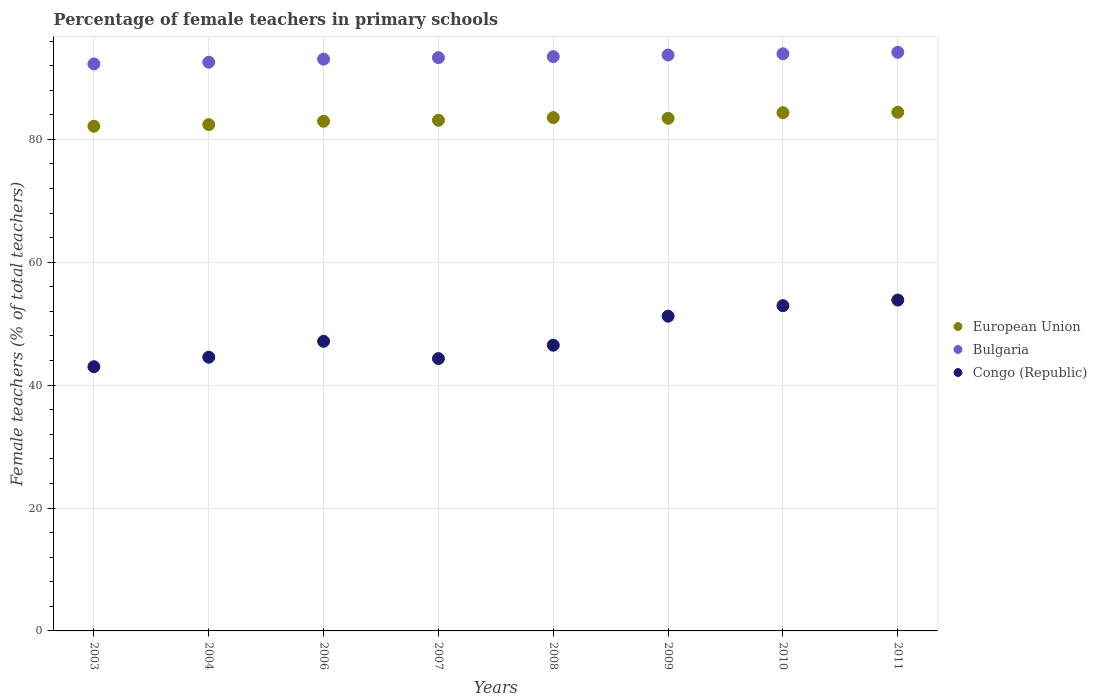How many different coloured dotlines are there?
Your answer should be very brief. 3. Is the number of dotlines equal to the number of legend labels?
Provide a short and direct response. Yes. What is the percentage of female teachers in European Union in 2004?
Make the answer very short. 82.4. Across all years, what is the maximum percentage of female teachers in Congo (Republic)?
Provide a short and direct response. 53.85. Across all years, what is the minimum percentage of female teachers in European Union?
Offer a very short reply. 82.14. In which year was the percentage of female teachers in Bulgaria maximum?
Offer a terse response. 2011. What is the total percentage of female teachers in European Union in the graph?
Provide a succinct answer. 666.35. What is the difference between the percentage of female teachers in European Union in 2003 and that in 2007?
Make the answer very short. -0.98. What is the difference between the percentage of female teachers in Congo (Republic) in 2009 and the percentage of female teachers in European Union in 2007?
Ensure brevity in your answer.  -31.89. What is the average percentage of female teachers in Bulgaria per year?
Offer a very short reply. 93.31. In the year 2009, what is the difference between the percentage of female teachers in European Union and percentage of female teachers in Bulgaria?
Ensure brevity in your answer.  -10.3. What is the ratio of the percentage of female teachers in European Union in 2007 to that in 2008?
Your response must be concise. 0.99. Is the percentage of female teachers in European Union in 2003 less than that in 2004?
Offer a terse response. Yes. Is the difference between the percentage of female teachers in European Union in 2006 and 2008 greater than the difference between the percentage of female teachers in Bulgaria in 2006 and 2008?
Ensure brevity in your answer.  No. What is the difference between the highest and the second highest percentage of female teachers in Bulgaria?
Provide a succinct answer. 0.24. What is the difference between the highest and the lowest percentage of female teachers in European Union?
Keep it short and to the point. 2.28. In how many years, is the percentage of female teachers in Bulgaria greater than the average percentage of female teachers in Bulgaria taken over all years?
Give a very brief answer. 4. Is the sum of the percentage of female teachers in Bulgaria in 2008 and 2009 greater than the maximum percentage of female teachers in European Union across all years?
Make the answer very short. Yes. Is the percentage of female teachers in Bulgaria strictly less than the percentage of female teachers in Congo (Republic) over the years?
Ensure brevity in your answer.  No. Does the graph contain any zero values?
Provide a short and direct response. No. Where does the legend appear in the graph?
Give a very brief answer. Center right. How many legend labels are there?
Your response must be concise. 3. What is the title of the graph?
Make the answer very short. Percentage of female teachers in primary schools. Does "Cabo Verde" appear as one of the legend labels in the graph?
Provide a succinct answer. No. What is the label or title of the X-axis?
Make the answer very short. Years. What is the label or title of the Y-axis?
Make the answer very short. Female teachers (% of total teachers). What is the Female teachers (% of total teachers) in European Union in 2003?
Keep it short and to the point. 82.14. What is the Female teachers (% of total teachers) in Bulgaria in 2003?
Your answer should be compact. 92.27. What is the Female teachers (% of total teachers) of Congo (Republic) in 2003?
Your response must be concise. 43. What is the Female teachers (% of total teachers) in European Union in 2004?
Keep it short and to the point. 82.4. What is the Female teachers (% of total teachers) of Bulgaria in 2004?
Your answer should be very brief. 92.56. What is the Female teachers (% of total teachers) of Congo (Republic) in 2004?
Offer a very short reply. 44.55. What is the Female teachers (% of total teachers) in European Union in 2006?
Your answer should be compact. 82.95. What is the Female teachers (% of total teachers) in Bulgaria in 2006?
Offer a terse response. 93.06. What is the Female teachers (% of total teachers) of Congo (Republic) in 2006?
Provide a short and direct response. 47.13. What is the Female teachers (% of total teachers) in European Union in 2007?
Give a very brief answer. 83.11. What is the Female teachers (% of total teachers) of Bulgaria in 2007?
Give a very brief answer. 93.3. What is the Female teachers (% of total teachers) in Congo (Republic) in 2007?
Provide a short and direct response. 44.32. What is the Female teachers (% of total teachers) of European Union in 2008?
Make the answer very short. 83.55. What is the Female teachers (% of total teachers) in Bulgaria in 2008?
Give a very brief answer. 93.47. What is the Female teachers (% of total teachers) of Congo (Republic) in 2008?
Keep it short and to the point. 46.5. What is the Female teachers (% of total teachers) in European Union in 2009?
Give a very brief answer. 83.43. What is the Female teachers (% of total teachers) in Bulgaria in 2009?
Provide a short and direct response. 93.73. What is the Female teachers (% of total teachers) in Congo (Republic) in 2009?
Give a very brief answer. 51.22. What is the Female teachers (% of total teachers) in European Union in 2010?
Keep it short and to the point. 84.35. What is the Female teachers (% of total teachers) in Bulgaria in 2010?
Ensure brevity in your answer.  93.93. What is the Female teachers (% of total teachers) of Congo (Republic) in 2010?
Offer a terse response. 52.94. What is the Female teachers (% of total teachers) in European Union in 2011?
Keep it short and to the point. 84.42. What is the Female teachers (% of total teachers) in Bulgaria in 2011?
Make the answer very short. 94.17. What is the Female teachers (% of total teachers) of Congo (Republic) in 2011?
Keep it short and to the point. 53.85. Across all years, what is the maximum Female teachers (% of total teachers) in European Union?
Make the answer very short. 84.42. Across all years, what is the maximum Female teachers (% of total teachers) in Bulgaria?
Provide a short and direct response. 94.17. Across all years, what is the maximum Female teachers (% of total teachers) of Congo (Republic)?
Ensure brevity in your answer.  53.85. Across all years, what is the minimum Female teachers (% of total teachers) in European Union?
Your response must be concise. 82.14. Across all years, what is the minimum Female teachers (% of total teachers) of Bulgaria?
Give a very brief answer. 92.27. Across all years, what is the minimum Female teachers (% of total teachers) of Congo (Republic)?
Make the answer very short. 43. What is the total Female teachers (% of total teachers) of European Union in the graph?
Your answer should be compact. 666.35. What is the total Female teachers (% of total teachers) of Bulgaria in the graph?
Your answer should be compact. 746.5. What is the total Female teachers (% of total teachers) in Congo (Republic) in the graph?
Provide a succinct answer. 383.52. What is the difference between the Female teachers (% of total teachers) in European Union in 2003 and that in 2004?
Provide a succinct answer. -0.27. What is the difference between the Female teachers (% of total teachers) in Bulgaria in 2003 and that in 2004?
Offer a terse response. -0.29. What is the difference between the Female teachers (% of total teachers) of Congo (Republic) in 2003 and that in 2004?
Ensure brevity in your answer.  -1.54. What is the difference between the Female teachers (% of total teachers) in European Union in 2003 and that in 2006?
Provide a short and direct response. -0.82. What is the difference between the Female teachers (% of total teachers) of Bulgaria in 2003 and that in 2006?
Give a very brief answer. -0.79. What is the difference between the Female teachers (% of total teachers) in Congo (Republic) in 2003 and that in 2006?
Your answer should be very brief. -4.13. What is the difference between the Female teachers (% of total teachers) of European Union in 2003 and that in 2007?
Keep it short and to the point. -0.98. What is the difference between the Female teachers (% of total teachers) of Bulgaria in 2003 and that in 2007?
Ensure brevity in your answer.  -1.03. What is the difference between the Female teachers (% of total teachers) in Congo (Republic) in 2003 and that in 2007?
Your response must be concise. -1.32. What is the difference between the Female teachers (% of total teachers) of European Union in 2003 and that in 2008?
Your answer should be very brief. -1.41. What is the difference between the Female teachers (% of total teachers) of Bulgaria in 2003 and that in 2008?
Your answer should be compact. -1.19. What is the difference between the Female teachers (% of total teachers) in Congo (Republic) in 2003 and that in 2008?
Give a very brief answer. -3.5. What is the difference between the Female teachers (% of total teachers) in European Union in 2003 and that in 2009?
Provide a short and direct response. -1.29. What is the difference between the Female teachers (% of total teachers) in Bulgaria in 2003 and that in 2009?
Your answer should be compact. -1.46. What is the difference between the Female teachers (% of total teachers) in Congo (Republic) in 2003 and that in 2009?
Make the answer very short. -8.22. What is the difference between the Female teachers (% of total teachers) of European Union in 2003 and that in 2010?
Your answer should be very brief. -2.21. What is the difference between the Female teachers (% of total teachers) in Bulgaria in 2003 and that in 2010?
Offer a very short reply. -1.66. What is the difference between the Female teachers (% of total teachers) of Congo (Republic) in 2003 and that in 2010?
Provide a succinct answer. -9.93. What is the difference between the Female teachers (% of total teachers) of European Union in 2003 and that in 2011?
Give a very brief answer. -2.28. What is the difference between the Female teachers (% of total teachers) in Bulgaria in 2003 and that in 2011?
Make the answer very short. -1.9. What is the difference between the Female teachers (% of total teachers) of Congo (Republic) in 2003 and that in 2011?
Make the answer very short. -10.85. What is the difference between the Female teachers (% of total teachers) of European Union in 2004 and that in 2006?
Provide a short and direct response. -0.55. What is the difference between the Female teachers (% of total teachers) in Bulgaria in 2004 and that in 2006?
Give a very brief answer. -0.5. What is the difference between the Female teachers (% of total teachers) in Congo (Republic) in 2004 and that in 2006?
Provide a succinct answer. -2.59. What is the difference between the Female teachers (% of total teachers) of European Union in 2004 and that in 2007?
Offer a terse response. -0.71. What is the difference between the Female teachers (% of total teachers) of Bulgaria in 2004 and that in 2007?
Your answer should be very brief. -0.74. What is the difference between the Female teachers (% of total teachers) of Congo (Republic) in 2004 and that in 2007?
Provide a succinct answer. 0.22. What is the difference between the Female teachers (% of total teachers) of European Union in 2004 and that in 2008?
Your answer should be compact. -1.15. What is the difference between the Female teachers (% of total teachers) in Bulgaria in 2004 and that in 2008?
Your answer should be compact. -0.91. What is the difference between the Female teachers (% of total teachers) of Congo (Republic) in 2004 and that in 2008?
Provide a succinct answer. -1.96. What is the difference between the Female teachers (% of total teachers) of European Union in 2004 and that in 2009?
Your answer should be compact. -1.03. What is the difference between the Female teachers (% of total teachers) in Bulgaria in 2004 and that in 2009?
Offer a terse response. -1.17. What is the difference between the Female teachers (% of total teachers) of Congo (Republic) in 2004 and that in 2009?
Offer a very short reply. -6.68. What is the difference between the Female teachers (% of total teachers) in European Union in 2004 and that in 2010?
Offer a terse response. -1.94. What is the difference between the Female teachers (% of total teachers) in Bulgaria in 2004 and that in 2010?
Make the answer very short. -1.37. What is the difference between the Female teachers (% of total teachers) in Congo (Republic) in 2004 and that in 2010?
Make the answer very short. -8.39. What is the difference between the Female teachers (% of total teachers) of European Union in 2004 and that in 2011?
Offer a terse response. -2.01. What is the difference between the Female teachers (% of total teachers) of Bulgaria in 2004 and that in 2011?
Your answer should be compact. -1.61. What is the difference between the Female teachers (% of total teachers) of Congo (Republic) in 2004 and that in 2011?
Your answer should be compact. -9.31. What is the difference between the Female teachers (% of total teachers) in European Union in 2006 and that in 2007?
Your answer should be compact. -0.16. What is the difference between the Female teachers (% of total teachers) of Bulgaria in 2006 and that in 2007?
Make the answer very short. -0.24. What is the difference between the Female teachers (% of total teachers) in Congo (Republic) in 2006 and that in 2007?
Give a very brief answer. 2.81. What is the difference between the Female teachers (% of total teachers) in European Union in 2006 and that in 2008?
Offer a terse response. -0.59. What is the difference between the Female teachers (% of total teachers) in Bulgaria in 2006 and that in 2008?
Make the answer very short. -0.41. What is the difference between the Female teachers (% of total teachers) in Congo (Republic) in 2006 and that in 2008?
Your answer should be very brief. 0.63. What is the difference between the Female teachers (% of total teachers) of European Union in 2006 and that in 2009?
Give a very brief answer. -0.48. What is the difference between the Female teachers (% of total teachers) in Bulgaria in 2006 and that in 2009?
Make the answer very short. -0.67. What is the difference between the Female teachers (% of total teachers) in Congo (Republic) in 2006 and that in 2009?
Provide a succinct answer. -4.09. What is the difference between the Female teachers (% of total teachers) of European Union in 2006 and that in 2010?
Keep it short and to the point. -1.39. What is the difference between the Female teachers (% of total teachers) of Bulgaria in 2006 and that in 2010?
Keep it short and to the point. -0.87. What is the difference between the Female teachers (% of total teachers) in Congo (Republic) in 2006 and that in 2010?
Your response must be concise. -5.81. What is the difference between the Female teachers (% of total teachers) in European Union in 2006 and that in 2011?
Give a very brief answer. -1.46. What is the difference between the Female teachers (% of total teachers) of Bulgaria in 2006 and that in 2011?
Offer a terse response. -1.11. What is the difference between the Female teachers (% of total teachers) of Congo (Republic) in 2006 and that in 2011?
Provide a succinct answer. -6.72. What is the difference between the Female teachers (% of total teachers) in European Union in 2007 and that in 2008?
Provide a short and direct response. -0.44. What is the difference between the Female teachers (% of total teachers) of Bulgaria in 2007 and that in 2008?
Your response must be concise. -0.17. What is the difference between the Female teachers (% of total teachers) in Congo (Republic) in 2007 and that in 2008?
Offer a very short reply. -2.18. What is the difference between the Female teachers (% of total teachers) of European Union in 2007 and that in 2009?
Your answer should be compact. -0.32. What is the difference between the Female teachers (% of total teachers) of Bulgaria in 2007 and that in 2009?
Ensure brevity in your answer.  -0.43. What is the difference between the Female teachers (% of total teachers) of Congo (Republic) in 2007 and that in 2009?
Ensure brevity in your answer.  -6.9. What is the difference between the Female teachers (% of total teachers) of European Union in 2007 and that in 2010?
Offer a very short reply. -1.23. What is the difference between the Female teachers (% of total teachers) in Bulgaria in 2007 and that in 2010?
Provide a succinct answer. -0.63. What is the difference between the Female teachers (% of total teachers) in Congo (Republic) in 2007 and that in 2010?
Provide a short and direct response. -8.61. What is the difference between the Female teachers (% of total teachers) of European Union in 2007 and that in 2011?
Offer a terse response. -1.3. What is the difference between the Female teachers (% of total teachers) in Bulgaria in 2007 and that in 2011?
Give a very brief answer. -0.87. What is the difference between the Female teachers (% of total teachers) in Congo (Republic) in 2007 and that in 2011?
Your answer should be compact. -9.53. What is the difference between the Female teachers (% of total teachers) of European Union in 2008 and that in 2009?
Your answer should be compact. 0.12. What is the difference between the Female teachers (% of total teachers) of Bulgaria in 2008 and that in 2009?
Give a very brief answer. -0.27. What is the difference between the Female teachers (% of total teachers) of Congo (Republic) in 2008 and that in 2009?
Make the answer very short. -4.72. What is the difference between the Female teachers (% of total teachers) in European Union in 2008 and that in 2010?
Ensure brevity in your answer.  -0.8. What is the difference between the Female teachers (% of total teachers) of Bulgaria in 2008 and that in 2010?
Ensure brevity in your answer.  -0.47. What is the difference between the Female teachers (% of total teachers) of Congo (Republic) in 2008 and that in 2010?
Give a very brief answer. -6.44. What is the difference between the Female teachers (% of total teachers) in European Union in 2008 and that in 2011?
Offer a very short reply. -0.87. What is the difference between the Female teachers (% of total teachers) in Bulgaria in 2008 and that in 2011?
Keep it short and to the point. -0.71. What is the difference between the Female teachers (% of total teachers) in Congo (Republic) in 2008 and that in 2011?
Provide a short and direct response. -7.35. What is the difference between the Female teachers (% of total teachers) in European Union in 2009 and that in 2010?
Offer a very short reply. -0.92. What is the difference between the Female teachers (% of total teachers) in Bulgaria in 2009 and that in 2010?
Make the answer very short. -0.2. What is the difference between the Female teachers (% of total teachers) of Congo (Republic) in 2009 and that in 2010?
Offer a very short reply. -1.72. What is the difference between the Female teachers (% of total teachers) in European Union in 2009 and that in 2011?
Your response must be concise. -0.98. What is the difference between the Female teachers (% of total teachers) in Bulgaria in 2009 and that in 2011?
Your answer should be very brief. -0.44. What is the difference between the Female teachers (% of total teachers) of Congo (Republic) in 2009 and that in 2011?
Give a very brief answer. -2.63. What is the difference between the Female teachers (% of total teachers) of European Union in 2010 and that in 2011?
Provide a succinct answer. -0.07. What is the difference between the Female teachers (% of total teachers) of Bulgaria in 2010 and that in 2011?
Offer a terse response. -0.24. What is the difference between the Female teachers (% of total teachers) of Congo (Republic) in 2010 and that in 2011?
Ensure brevity in your answer.  -0.92. What is the difference between the Female teachers (% of total teachers) in European Union in 2003 and the Female teachers (% of total teachers) in Bulgaria in 2004?
Offer a very short reply. -10.42. What is the difference between the Female teachers (% of total teachers) of European Union in 2003 and the Female teachers (% of total teachers) of Congo (Republic) in 2004?
Your answer should be compact. 37.59. What is the difference between the Female teachers (% of total teachers) of Bulgaria in 2003 and the Female teachers (% of total teachers) of Congo (Republic) in 2004?
Make the answer very short. 47.73. What is the difference between the Female teachers (% of total teachers) of European Union in 2003 and the Female teachers (% of total teachers) of Bulgaria in 2006?
Ensure brevity in your answer.  -10.92. What is the difference between the Female teachers (% of total teachers) of European Union in 2003 and the Female teachers (% of total teachers) of Congo (Republic) in 2006?
Provide a succinct answer. 35.01. What is the difference between the Female teachers (% of total teachers) of Bulgaria in 2003 and the Female teachers (% of total teachers) of Congo (Republic) in 2006?
Your answer should be very brief. 45.14. What is the difference between the Female teachers (% of total teachers) in European Union in 2003 and the Female teachers (% of total teachers) in Bulgaria in 2007?
Your answer should be compact. -11.16. What is the difference between the Female teachers (% of total teachers) of European Union in 2003 and the Female teachers (% of total teachers) of Congo (Republic) in 2007?
Offer a terse response. 37.81. What is the difference between the Female teachers (% of total teachers) of Bulgaria in 2003 and the Female teachers (% of total teachers) of Congo (Republic) in 2007?
Offer a terse response. 47.95. What is the difference between the Female teachers (% of total teachers) of European Union in 2003 and the Female teachers (% of total teachers) of Bulgaria in 2008?
Provide a succinct answer. -11.33. What is the difference between the Female teachers (% of total teachers) in European Union in 2003 and the Female teachers (% of total teachers) in Congo (Republic) in 2008?
Provide a succinct answer. 35.63. What is the difference between the Female teachers (% of total teachers) of Bulgaria in 2003 and the Female teachers (% of total teachers) of Congo (Republic) in 2008?
Ensure brevity in your answer.  45.77. What is the difference between the Female teachers (% of total teachers) in European Union in 2003 and the Female teachers (% of total teachers) in Bulgaria in 2009?
Offer a very short reply. -11.59. What is the difference between the Female teachers (% of total teachers) of European Union in 2003 and the Female teachers (% of total teachers) of Congo (Republic) in 2009?
Offer a terse response. 30.92. What is the difference between the Female teachers (% of total teachers) in Bulgaria in 2003 and the Female teachers (% of total teachers) in Congo (Republic) in 2009?
Provide a short and direct response. 41.05. What is the difference between the Female teachers (% of total teachers) in European Union in 2003 and the Female teachers (% of total teachers) in Bulgaria in 2010?
Your response must be concise. -11.8. What is the difference between the Female teachers (% of total teachers) of European Union in 2003 and the Female teachers (% of total teachers) of Congo (Republic) in 2010?
Give a very brief answer. 29.2. What is the difference between the Female teachers (% of total teachers) of Bulgaria in 2003 and the Female teachers (% of total teachers) of Congo (Republic) in 2010?
Ensure brevity in your answer.  39.34. What is the difference between the Female teachers (% of total teachers) in European Union in 2003 and the Female teachers (% of total teachers) in Bulgaria in 2011?
Keep it short and to the point. -12.04. What is the difference between the Female teachers (% of total teachers) in European Union in 2003 and the Female teachers (% of total teachers) in Congo (Republic) in 2011?
Your answer should be very brief. 28.28. What is the difference between the Female teachers (% of total teachers) in Bulgaria in 2003 and the Female teachers (% of total teachers) in Congo (Republic) in 2011?
Your answer should be very brief. 38.42. What is the difference between the Female teachers (% of total teachers) of European Union in 2004 and the Female teachers (% of total teachers) of Bulgaria in 2006?
Provide a short and direct response. -10.66. What is the difference between the Female teachers (% of total teachers) of European Union in 2004 and the Female teachers (% of total teachers) of Congo (Republic) in 2006?
Provide a succinct answer. 35.27. What is the difference between the Female teachers (% of total teachers) in Bulgaria in 2004 and the Female teachers (% of total teachers) in Congo (Republic) in 2006?
Your response must be concise. 45.43. What is the difference between the Female teachers (% of total teachers) of European Union in 2004 and the Female teachers (% of total teachers) of Bulgaria in 2007?
Your answer should be compact. -10.9. What is the difference between the Female teachers (% of total teachers) in European Union in 2004 and the Female teachers (% of total teachers) in Congo (Republic) in 2007?
Give a very brief answer. 38.08. What is the difference between the Female teachers (% of total teachers) in Bulgaria in 2004 and the Female teachers (% of total teachers) in Congo (Republic) in 2007?
Keep it short and to the point. 48.24. What is the difference between the Female teachers (% of total teachers) in European Union in 2004 and the Female teachers (% of total teachers) in Bulgaria in 2008?
Offer a terse response. -11.06. What is the difference between the Female teachers (% of total teachers) in European Union in 2004 and the Female teachers (% of total teachers) in Congo (Republic) in 2008?
Provide a succinct answer. 35.9. What is the difference between the Female teachers (% of total teachers) in Bulgaria in 2004 and the Female teachers (% of total teachers) in Congo (Republic) in 2008?
Provide a short and direct response. 46.06. What is the difference between the Female teachers (% of total teachers) of European Union in 2004 and the Female teachers (% of total teachers) of Bulgaria in 2009?
Provide a succinct answer. -11.33. What is the difference between the Female teachers (% of total teachers) in European Union in 2004 and the Female teachers (% of total teachers) in Congo (Republic) in 2009?
Your answer should be compact. 31.18. What is the difference between the Female teachers (% of total teachers) of Bulgaria in 2004 and the Female teachers (% of total teachers) of Congo (Republic) in 2009?
Offer a terse response. 41.34. What is the difference between the Female teachers (% of total teachers) in European Union in 2004 and the Female teachers (% of total teachers) in Bulgaria in 2010?
Offer a terse response. -11.53. What is the difference between the Female teachers (% of total teachers) of European Union in 2004 and the Female teachers (% of total teachers) of Congo (Republic) in 2010?
Make the answer very short. 29.46. What is the difference between the Female teachers (% of total teachers) of Bulgaria in 2004 and the Female teachers (% of total teachers) of Congo (Republic) in 2010?
Provide a short and direct response. 39.62. What is the difference between the Female teachers (% of total teachers) in European Union in 2004 and the Female teachers (% of total teachers) in Bulgaria in 2011?
Provide a succinct answer. -11.77. What is the difference between the Female teachers (% of total teachers) in European Union in 2004 and the Female teachers (% of total teachers) in Congo (Republic) in 2011?
Your answer should be compact. 28.55. What is the difference between the Female teachers (% of total teachers) of Bulgaria in 2004 and the Female teachers (% of total teachers) of Congo (Republic) in 2011?
Make the answer very short. 38.71. What is the difference between the Female teachers (% of total teachers) of European Union in 2006 and the Female teachers (% of total teachers) of Bulgaria in 2007?
Your answer should be compact. -10.34. What is the difference between the Female teachers (% of total teachers) in European Union in 2006 and the Female teachers (% of total teachers) in Congo (Republic) in 2007?
Make the answer very short. 38.63. What is the difference between the Female teachers (% of total teachers) in Bulgaria in 2006 and the Female teachers (% of total teachers) in Congo (Republic) in 2007?
Make the answer very short. 48.74. What is the difference between the Female teachers (% of total teachers) of European Union in 2006 and the Female teachers (% of total teachers) of Bulgaria in 2008?
Offer a terse response. -10.51. What is the difference between the Female teachers (% of total teachers) in European Union in 2006 and the Female teachers (% of total teachers) in Congo (Republic) in 2008?
Give a very brief answer. 36.45. What is the difference between the Female teachers (% of total teachers) of Bulgaria in 2006 and the Female teachers (% of total teachers) of Congo (Republic) in 2008?
Ensure brevity in your answer.  46.56. What is the difference between the Female teachers (% of total teachers) of European Union in 2006 and the Female teachers (% of total teachers) of Bulgaria in 2009?
Provide a succinct answer. -10.78. What is the difference between the Female teachers (% of total teachers) in European Union in 2006 and the Female teachers (% of total teachers) in Congo (Republic) in 2009?
Provide a short and direct response. 31.73. What is the difference between the Female teachers (% of total teachers) of Bulgaria in 2006 and the Female teachers (% of total teachers) of Congo (Republic) in 2009?
Offer a terse response. 41.84. What is the difference between the Female teachers (% of total teachers) of European Union in 2006 and the Female teachers (% of total teachers) of Bulgaria in 2010?
Your response must be concise. -10.98. What is the difference between the Female teachers (% of total teachers) in European Union in 2006 and the Female teachers (% of total teachers) in Congo (Republic) in 2010?
Offer a terse response. 30.02. What is the difference between the Female teachers (% of total teachers) of Bulgaria in 2006 and the Female teachers (% of total teachers) of Congo (Republic) in 2010?
Your response must be concise. 40.12. What is the difference between the Female teachers (% of total teachers) in European Union in 2006 and the Female teachers (% of total teachers) in Bulgaria in 2011?
Keep it short and to the point. -11.22. What is the difference between the Female teachers (% of total teachers) in European Union in 2006 and the Female teachers (% of total teachers) in Congo (Republic) in 2011?
Your response must be concise. 29.1. What is the difference between the Female teachers (% of total teachers) of Bulgaria in 2006 and the Female teachers (% of total teachers) of Congo (Republic) in 2011?
Your answer should be compact. 39.21. What is the difference between the Female teachers (% of total teachers) of European Union in 2007 and the Female teachers (% of total teachers) of Bulgaria in 2008?
Provide a short and direct response. -10.35. What is the difference between the Female teachers (% of total teachers) of European Union in 2007 and the Female teachers (% of total teachers) of Congo (Republic) in 2008?
Your answer should be compact. 36.61. What is the difference between the Female teachers (% of total teachers) in Bulgaria in 2007 and the Female teachers (% of total teachers) in Congo (Republic) in 2008?
Offer a terse response. 46.8. What is the difference between the Female teachers (% of total teachers) in European Union in 2007 and the Female teachers (% of total teachers) in Bulgaria in 2009?
Provide a short and direct response. -10.62. What is the difference between the Female teachers (% of total teachers) in European Union in 2007 and the Female teachers (% of total teachers) in Congo (Republic) in 2009?
Make the answer very short. 31.89. What is the difference between the Female teachers (% of total teachers) in Bulgaria in 2007 and the Female teachers (% of total teachers) in Congo (Republic) in 2009?
Offer a very short reply. 42.08. What is the difference between the Female teachers (% of total teachers) in European Union in 2007 and the Female teachers (% of total teachers) in Bulgaria in 2010?
Provide a succinct answer. -10.82. What is the difference between the Female teachers (% of total teachers) of European Union in 2007 and the Female teachers (% of total teachers) of Congo (Republic) in 2010?
Provide a short and direct response. 30.18. What is the difference between the Female teachers (% of total teachers) of Bulgaria in 2007 and the Female teachers (% of total teachers) of Congo (Republic) in 2010?
Provide a short and direct response. 40.36. What is the difference between the Female teachers (% of total teachers) of European Union in 2007 and the Female teachers (% of total teachers) of Bulgaria in 2011?
Ensure brevity in your answer.  -11.06. What is the difference between the Female teachers (% of total teachers) in European Union in 2007 and the Female teachers (% of total teachers) in Congo (Republic) in 2011?
Offer a terse response. 29.26. What is the difference between the Female teachers (% of total teachers) of Bulgaria in 2007 and the Female teachers (% of total teachers) of Congo (Republic) in 2011?
Offer a terse response. 39.45. What is the difference between the Female teachers (% of total teachers) in European Union in 2008 and the Female teachers (% of total teachers) in Bulgaria in 2009?
Ensure brevity in your answer.  -10.18. What is the difference between the Female teachers (% of total teachers) of European Union in 2008 and the Female teachers (% of total teachers) of Congo (Republic) in 2009?
Your response must be concise. 32.33. What is the difference between the Female teachers (% of total teachers) of Bulgaria in 2008 and the Female teachers (% of total teachers) of Congo (Republic) in 2009?
Provide a succinct answer. 42.24. What is the difference between the Female teachers (% of total teachers) of European Union in 2008 and the Female teachers (% of total teachers) of Bulgaria in 2010?
Provide a succinct answer. -10.38. What is the difference between the Female teachers (% of total teachers) in European Union in 2008 and the Female teachers (% of total teachers) in Congo (Republic) in 2010?
Provide a short and direct response. 30.61. What is the difference between the Female teachers (% of total teachers) of Bulgaria in 2008 and the Female teachers (% of total teachers) of Congo (Republic) in 2010?
Your answer should be compact. 40.53. What is the difference between the Female teachers (% of total teachers) of European Union in 2008 and the Female teachers (% of total teachers) of Bulgaria in 2011?
Provide a succinct answer. -10.62. What is the difference between the Female teachers (% of total teachers) of European Union in 2008 and the Female teachers (% of total teachers) of Congo (Republic) in 2011?
Make the answer very short. 29.7. What is the difference between the Female teachers (% of total teachers) in Bulgaria in 2008 and the Female teachers (% of total teachers) in Congo (Republic) in 2011?
Provide a succinct answer. 39.61. What is the difference between the Female teachers (% of total teachers) in European Union in 2009 and the Female teachers (% of total teachers) in Bulgaria in 2010?
Provide a short and direct response. -10.5. What is the difference between the Female teachers (% of total teachers) of European Union in 2009 and the Female teachers (% of total teachers) of Congo (Republic) in 2010?
Keep it short and to the point. 30.49. What is the difference between the Female teachers (% of total teachers) in Bulgaria in 2009 and the Female teachers (% of total teachers) in Congo (Republic) in 2010?
Keep it short and to the point. 40.79. What is the difference between the Female teachers (% of total teachers) in European Union in 2009 and the Female teachers (% of total teachers) in Bulgaria in 2011?
Your answer should be very brief. -10.74. What is the difference between the Female teachers (% of total teachers) in European Union in 2009 and the Female teachers (% of total teachers) in Congo (Republic) in 2011?
Keep it short and to the point. 29.58. What is the difference between the Female teachers (% of total teachers) in Bulgaria in 2009 and the Female teachers (% of total teachers) in Congo (Republic) in 2011?
Offer a terse response. 39.88. What is the difference between the Female teachers (% of total teachers) in European Union in 2010 and the Female teachers (% of total teachers) in Bulgaria in 2011?
Provide a succinct answer. -9.83. What is the difference between the Female teachers (% of total teachers) in European Union in 2010 and the Female teachers (% of total teachers) in Congo (Republic) in 2011?
Offer a very short reply. 30.49. What is the difference between the Female teachers (% of total teachers) in Bulgaria in 2010 and the Female teachers (% of total teachers) in Congo (Republic) in 2011?
Provide a succinct answer. 40.08. What is the average Female teachers (% of total teachers) of European Union per year?
Keep it short and to the point. 83.29. What is the average Female teachers (% of total teachers) in Bulgaria per year?
Ensure brevity in your answer.  93.31. What is the average Female teachers (% of total teachers) in Congo (Republic) per year?
Your answer should be compact. 47.94. In the year 2003, what is the difference between the Female teachers (% of total teachers) in European Union and Female teachers (% of total teachers) in Bulgaria?
Offer a very short reply. -10.14. In the year 2003, what is the difference between the Female teachers (% of total teachers) of European Union and Female teachers (% of total teachers) of Congo (Republic)?
Your answer should be very brief. 39.13. In the year 2003, what is the difference between the Female teachers (% of total teachers) in Bulgaria and Female teachers (% of total teachers) in Congo (Republic)?
Offer a terse response. 49.27. In the year 2004, what is the difference between the Female teachers (% of total teachers) in European Union and Female teachers (% of total teachers) in Bulgaria?
Your response must be concise. -10.16. In the year 2004, what is the difference between the Female teachers (% of total teachers) in European Union and Female teachers (% of total teachers) in Congo (Republic)?
Offer a very short reply. 37.86. In the year 2004, what is the difference between the Female teachers (% of total teachers) in Bulgaria and Female teachers (% of total teachers) in Congo (Republic)?
Provide a short and direct response. 48.01. In the year 2006, what is the difference between the Female teachers (% of total teachers) in European Union and Female teachers (% of total teachers) in Bulgaria?
Give a very brief answer. -10.11. In the year 2006, what is the difference between the Female teachers (% of total teachers) of European Union and Female teachers (% of total teachers) of Congo (Republic)?
Keep it short and to the point. 35.82. In the year 2006, what is the difference between the Female teachers (% of total teachers) in Bulgaria and Female teachers (% of total teachers) in Congo (Republic)?
Keep it short and to the point. 45.93. In the year 2007, what is the difference between the Female teachers (% of total teachers) of European Union and Female teachers (% of total teachers) of Bulgaria?
Ensure brevity in your answer.  -10.19. In the year 2007, what is the difference between the Female teachers (% of total teachers) in European Union and Female teachers (% of total teachers) in Congo (Republic)?
Give a very brief answer. 38.79. In the year 2007, what is the difference between the Female teachers (% of total teachers) of Bulgaria and Female teachers (% of total teachers) of Congo (Republic)?
Provide a succinct answer. 48.98. In the year 2008, what is the difference between the Female teachers (% of total teachers) in European Union and Female teachers (% of total teachers) in Bulgaria?
Ensure brevity in your answer.  -9.92. In the year 2008, what is the difference between the Female teachers (% of total teachers) of European Union and Female teachers (% of total teachers) of Congo (Republic)?
Provide a succinct answer. 37.05. In the year 2008, what is the difference between the Female teachers (% of total teachers) in Bulgaria and Female teachers (% of total teachers) in Congo (Republic)?
Your answer should be compact. 46.96. In the year 2009, what is the difference between the Female teachers (% of total teachers) in European Union and Female teachers (% of total teachers) in Bulgaria?
Your response must be concise. -10.3. In the year 2009, what is the difference between the Female teachers (% of total teachers) in European Union and Female teachers (% of total teachers) in Congo (Republic)?
Make the answer very short. 32.21. In the year 2009, what is the difference between the Female teachers (% of total teachers) of Bulgaria and Female teachers (% of total teachers) of Congo (Republic)?
Your answer should be compact. 42.51. In the year 2010, what is the difference between the Female teachers (% of total teachers) in European Union and Female teachers (% of total teachers) in Bulgaria?
Provide a short and direct response. -9.59. In the year 2010, what is the difference between the Female teachers (% of total teachers) of European Union and Female teachers (% of total teachers) of Congo (Republic)?
Ensure brevity in your answer.  31.41. In the year 2010, what is the difference between the Female teachers (% of total teachers) of Bulgaria and Female teachers (% of total teachers) of Congo (Republic)?
Offer a terse response. 41. In the year 2011, what is the difference between the Female teachers (% of total teachers) of European Union and Female teachers (% of total teachers) of Bulgaria?
Keep it short and to the point. -9.76. In the year 2011, what is the difference between the Female teachers (% of total teachers) of European Union and Female teachers (% of total teachers) of Congo (Republic)?
Make the answer very short. 30.56. In the year 2011, what is the difference between the Female teachers (% of total teachers) of Bulgaria and Female teachers (% of total teachers) of Congo (Republic)?
Offer a very short reply. 40.32. What is the ratio of the Female teachers (% of total teachers) of European Union in 2003 to that in 2004?
Ensure brevity in your answer.  1. What is the ratio of the Female teachers (% of total teachers) in Bulgaria in 2003 to that in 2004?
Offer a very short reply. 1. What is the ratio of the Female teachers (% of total teachers) of Congo (Republic) in 2003 to that in 2004?
Offer a very short reply. 0.97. What is the ratio of the Female teachers (% of total teachers) in Bulgaria in 2003 to that in 2006?
Offer a terse response. 0.99. What is the ratio of the Female teachers (% of total teachers) of Congo (Republic) in 2003 to that in 2006?
Offer a terse response. 0.91. What is the ratio of the Female teachers (% of total teachers) in European Union in 2003 to that in 2007?
Keep it short and to the point. 0.99. What is the ratio of the Female teachers (% of total teachers) in Bulgaria in 2003 to that in 2007?
Provide a succinct answer. 0.99. What is the ratio of the Female teachers (% of total teachers) of Congo (Republic) in 2003 to that in 2007?
Your response must be concise. 0.97. What is the ratio of the Female teachers (% of total teachers) of European Union in 2003 to that in 2008?
Ensure brevity in your answer.  0.98. What is the ratio of the Female teachers (% of total teachers) of Bulgaria in 2003 to that in 2008?
Offer a very short reply. 0.99. What is the ratio of the Female teachers (% of total teachers) in Congo (Republic) in 2003 to that in 2008?
Give a very brief answer. 0.92. What is the ratio of the Female teachers (% of total teachers) of European Union in 2003 to that in 2009?
Give a very brief answer. 0.98. What is the ratio of the Female teachers (% of total teachers) of Bulgaria in 2003 to that in 2009?
Offer a terse response. 0.98. What is the ratio of the Female teachers (% of total teachers) in Congo (Republic) in 2003 to that in 2009?
Give a very brief answer. 0.84. What is the ratio of the Female teachers (% of total teachers) of European Union in 2003 to that in 2010?
Provide a succinct answer. 0.97. What is the ratio of the Female teachers (% of total teachers) in Bulgaria in 2003 to that in 2010?
Your answer should be very brief. 0.98. What is the ratio of the Female teachers (% of total teachers) of Congo (Republic) in 2003 to that in 2010?
Your answer should be very brief. 0.81. What is the ratio of the Female teachers (% of total teachers) in Bulgaria in 2003 to that in 2011?
Keep it short and to the point. 0.98. What is the ratio of the Female teachers (% of total teachers) in Congo (Republic) in 2003 to that in 2011?
Your response must be concise. 0.8. What is the ratio of the Female teachers (% of total teachers) in European Union in 2004 to that in 2006?
Your response must be concise. 0.99. What is the ratio of the Female teachers (% of total teachers) in Bulgaria in 2004 to that in 2006?
Your response must be concise. 0.99. What is the ratio of the Female teachers (% of total teachers) in Congo (Republic) in 2004 to that in 2006?
Keep it short and to the point. 0.95. What is the ratio of the Female teachers (% of total teachers) of European Union in 2004 to that in 2007?
Your answer should be compact. 0.99. What is the ratio of the Female teachers (% of total teachers) of Congo (Republic) in 2004 to that in 2007?
Make the answer very short. 1. What is the ratio of the Female teachers (% of total teachers) of European Union in 2004 to that in 2008?
Your answer should be compact. 0.99. What is the ratio of the Female teachers (% of total teachers) of Bulgaria in 2004 to that in 2008?
Give a very brief answer. 0.99. What is the ratio of the Female teachers (% of total teachers) in Congo (Republic) in 2004 to that in 2008?
Offer a terse response. 0.96. What is the ratio of the Female teachers (% of total teachers) of Bulgaria in 2004 to that in 2009?
Your response must be concise. 0.99. What is the ratio of the Female teachers (% of total teachers) in Congo (Republic) in 2004 to that in 2009?
Make the answer very short. 0.87. What is the ratio of the Female teachers (% of total teachers) in European Union in 2004 to that in 2010?
Keep it short and to the point. 0.98. What is the ratio of the Female teachers (% of total teachers) of Bulgaria in 2004 to that in 2010?
Provide a succinct answer. 0.99. What is the ratio of the Female teachers (% of total teachers) in Congo (Republic) in 2004 to that in 2010?
Provide a short and direct response. 0.84. What is the ratio of the Female teachers (% of total teachers) in European Union in 2004 to that in 2011?
Provide a short and direct response. 0.98. What is the ratio of the Female teachers (% of total teachers) of Bulgaria in 2004 to that in 2011?
Keep it short and to the point. 0.98. What is the ratio of the Female teachers (% of total teachers) of Congo (Republic) in 2004 to that in 2011?
Ensure brevity in your answer.  0.83. What is the ratio of the Female teachers (% of total teachers) in European Union in 2006 to that in 2007?
Make the answer very short. 1. What is the ratio of the Female teachers (% of total teachers) in Bulgaria in 2006 to that in 2007?
Offer a very short reply. 1. What is the ratio of the Female teachers (% of total teachers) in Congo (Republic) in 2006 to that in 2007?
Give a very brief answer. 1.06. What is the ratio of the Female teachers (% of total teachers) of Congo (Republic) in 2006 to that in 2008?
Ensure brevity in your answer.  1.01. What is the ratio of the Female teachers (% of total teachers) in European Union in 2006 to that in 2009?
Provide a short and direct response. 0.99. What is the ratio of the Female teachers (% of total teachers) in Bulgaria in 2006 to that in 2009?
Your answer should be compact. 0.99. What is the ratio of the Female teachers (% of total teachers) in Congo (Republic) in 2006 to that in 2009?
Your answer should be very brief. 0.92. What is the ratio of the Female teachers (% of total teachers) in European Union in 2006 to that in 2010?
Your response must be concise. 0.98. What is the ratio of the Female teachers (% of total teachers) in Bulgaria in 2006 to that in 2010?
Provide a succinct answer. 0.99. What is the ratio of the Female teachers (% of total teachers) of Congo (Republic) in 2006 to that in 2010?
Offer a terse response. 0.89. What is the ratio of the Female teachers (% of total teachers) in European Union in 2006 to that in 2011?
Give a very brief answer. 0.98. What is the ratio of the Female teachers (% of total teachers) in Congo (Republic) in 2006 to that in 2011?
Provide a succinct answer. 0.88. What is the ratio of the Female teachers (% of total teachers) in Bulgaria in 2007 to that in 2008?
Offer a terse response. 1. What is the ratio of the Female teachers (% of total teachers) in Congo (Republic) in 2007 to that in 2008?
Provide a succinct answer. 0.95. What is the ratio of the Female teachers (% of total teachers) of European Union in 2007 to that in 2009?
Provide a succinct answer. 1. What is the ratio of the Female teachers (% of total teachers) of Bulgaria in 2007 to that in 2009?
Your answer should be compact. 1. What is the ratio of the Female teachers (% of total teachers) in Congo (Republic) in 2007 to that in 2009?
Ensure brevity in your answer.  0.87. What is the ratio of the Female teachers (% of total teachers) in European Union in 2007 to that in 2010?
Provide a short and direct response. 0.99. What is the ratio of the Female teachers (% of total teachers) of Bulgaria in 2007 to that in 2010?
Your answer should be compact. 0.99. What is the ratio of the Female teachers (% of total teachers) in Congo (Republic) in 2007 to that in 2010?
Make the answer very short. 0.84. What is the ratio of the Female teachers (% of total teachers) in European Union in 2007 to that in 2011?
Your response must be concise. 0.98. What is the ratio of the Female teachers (% of total teachers) in Congo (Republic) in 2007 to that in 2011?
Your answer should be very brief. 0.82. What is the ratio of the Female teachers (% of total teachers) in European Union in 2008 to that in 2009?
Your answer should be very brief. 1. What is the ratio of the Female teachers (% of total teachers) in Congo (Republic) in 2008 to that in 2009?
Your answer should be compact. 0.91. What is the ratio of the Female teachers (% of total teachers) in Congo (Republic) in 2008 to that in 2010?
Offer a terse response. 0.88. What is the ratio of the Female teachers (% of total teachers) in European Union in 2008 to that in 2011?
Provide a succinct answer. 0.99. What is the ratio of the Female teachers (% of total teachers) in Congo (Republic) in 2008 to that in 2011?
Offer a very short reply. 0.86. What is the ratio of the Female teachers (% of total teachers) of Congo (Republic) in 2009 to that in 2010?
Give a very brief answer. 0.97. What is the ratio of the Female teachers (% of total teachers) of European Union in 2009 to that in 2011?
Keep it short and to the point. 0.99. What is the ratio of the Female teachers (% of total teachers) of Bulgaria in 2009 to that in 2011?
Provide a short and direct response. 1. What is the ratio of the Female teachers (% of total teachers) of Congo (Republic) in 2009 to that in 2011?
Keep it short and to the point. 0.95. What is the ratio of the Female teachers (% of total teachers) of European Union in 2010 to that in 2011?
Give a very brief answer. 1. What is the difference between the highest and the second highest Female teachers (% of total teachers) of European Union?
Your response must be concise. 0.07. What is the difference between the highest and the second highest Female teachers (% of total teachers) in Bulgaria?
Offer a very short reply. 0.24. What is the difference between the highest and the second highest Female teachers (% of total teachers) in Congo (Republic)?
Give a very brief answer. 0.92. What is the difference between the highest and the lowest Female teachers (% of total teachers) of European Union?
Make the answer very short. 2.28. What is the difference between the highest and the lowest Female teachers (% of total teachers) of Bulgaria?
Make the answer very short. 1.9. What is the difference between the highest and the lowest Female teachers (% of total teachers) in Congo (Republic)?
Make the answer very short. 10.85. 